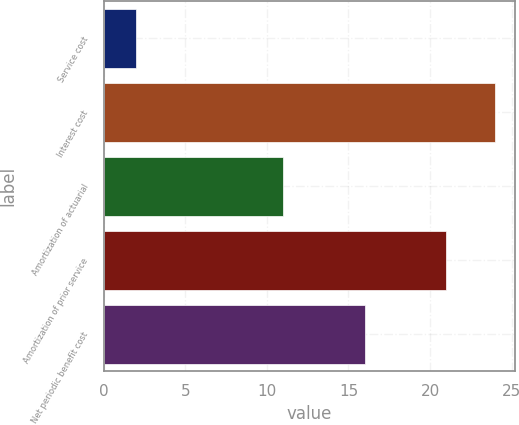Convert chart to OTSL. <chart><loc_0><loc_0><loc_500><loc_500><bar_chart><fcel>Service cost<fcel>Interest cost<fcel>Amortization of actuarial<fcel>Amortization of prior service<fcel>Net periodic benefit cost<nl><fcel>2<fcel>24<fcel>11<fcel>21<fcel>16<nl></chart> 